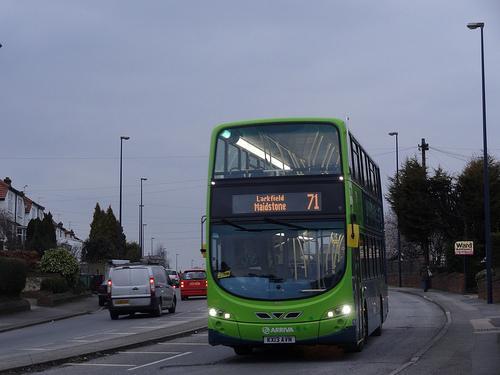How many buses are there?
Give a very brief answer. 1. 